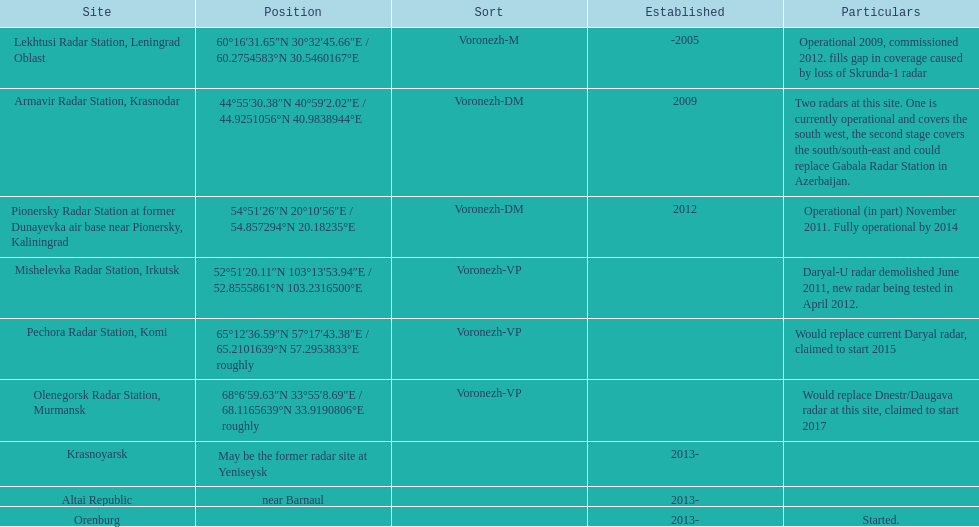In which year was the top built? -2005. 